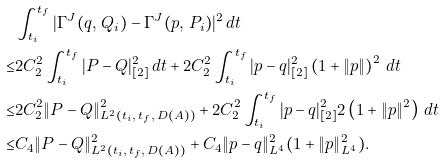<formula> <loc_0><loc_0><loc_500><loc_500>& \int _ { t _ { i } } ^ { t _ { f } } | \Gamma ^ { J } ( q , \, Q _ { i } ) - \Gamma ^ { J } ( p , \, P _ { i } ) | ^ { 2 } \, d t \\ \leq & 2 C _ { 2 } ^ { 2 } \int _ { t _ { i } } ^ { t _ { f } } | P - Q | _ { [ 2 ] } ^ { 2 } \, d t + 2 C _ { 2 } ^ { 2 } \int _ { t _ { i } } ^ { t _ { f } } | p - q | _ { [ 2 ] } ^ { 2 } \left ( 1 + \| p \| \right ) ^ { 2 } \, d t \\ \leq & 2 C _ { 2 } ^ { 2 } \| P - Q \| _ { L ^ { 2 } ( t _ { i } , \, t _ { f } , \, D ( A ) ) } ^ { 2 } + 2 C _ { 2 } ^ { 2 } \int _ { t _ { i } } ^ { t _ { f } } | p - q | _ { [ 2 ] } ^ { 2 } 2 \left ( 1 + \| p \| ^ { 2 } \right ) \, d t \\ \leq & C _ { 4 } \| P - Q \| _ { L ^ { 2 } ( t _ { i } , \, t _ { f } , \, D ( A ) ) } ^ { 2 } + C _ { 4 } \| p - q \| _ { L ^ { 4 } } ^ { 2 } ( 1 + \| p \| _ { L ^ { 4 } } ^ { 2 } ) .</formula> 